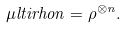<formula> <loc_0><loc_0><loc_500><loc_500>\mu l t i r h o n = \rho ^ { \otimes n } .</formula> 